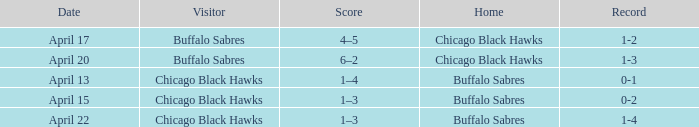Which Date has a Record of 1-4? April 22. 